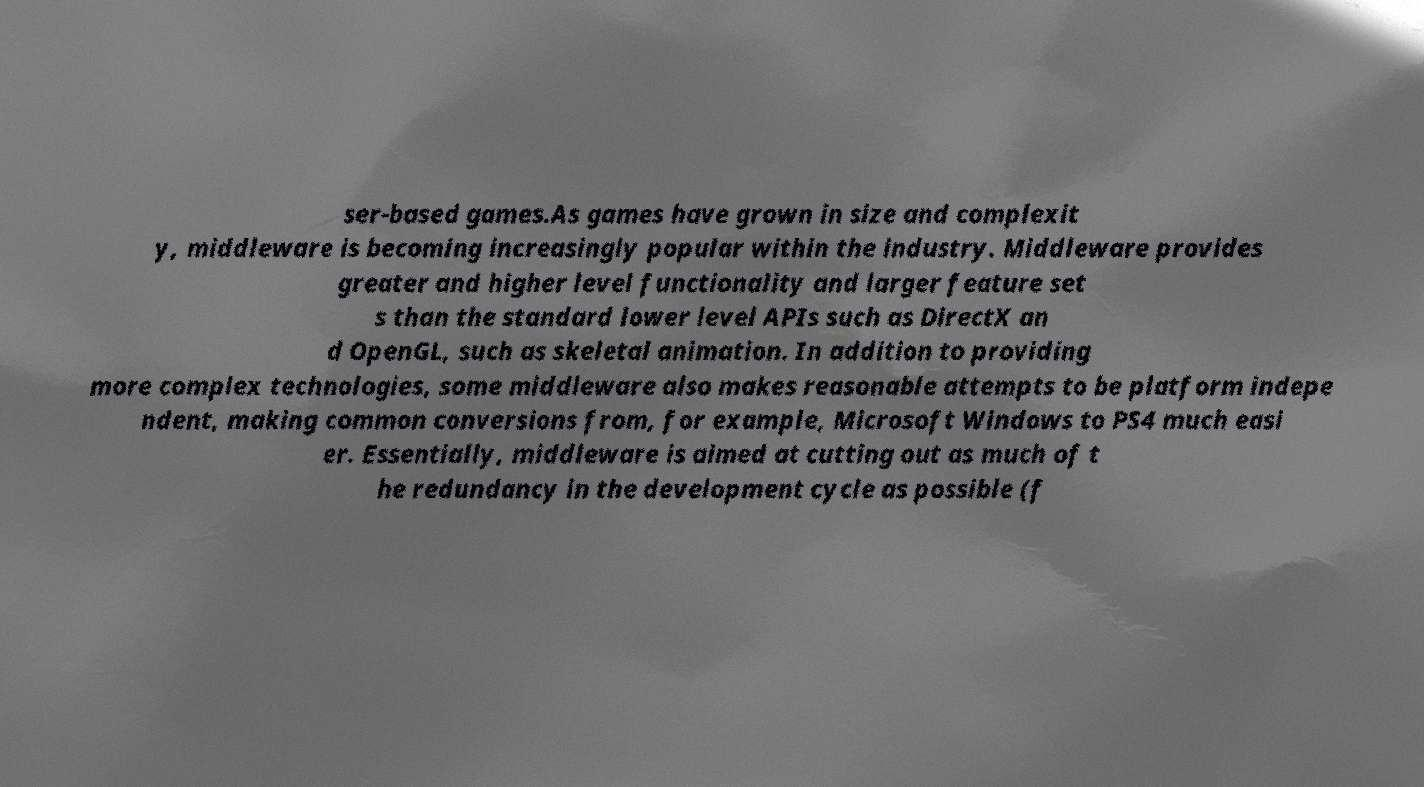Could you extract and type out the text from this image? ser-based games.As games have grown in size and complexit y, middleware is becoming increasingly popular within the industry. Middleware provides greater and higher level functionality and larger feature set s than the standard lower level APIs such as DirectX an d OpenGL, such as skeletal animation. In addition to providing more complex technologies, some middleware also makes reasonable attempts to be platform indepe ndent, making common conversions from, for example, Microsoft Windows to PS4 much easi er. Essentially, middleware is aimed at cutting out as much of t he redundancy in the development cycle as possible (f 